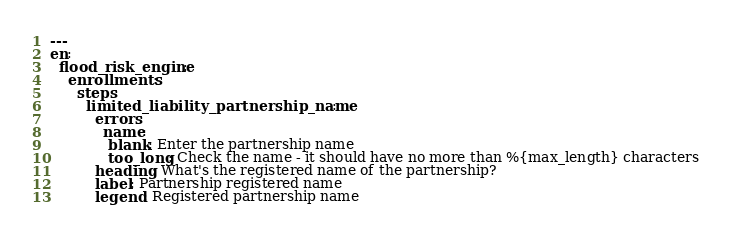Convert code to text. <code><loc_0><loc_0><loc_500><loc_500><_YAML_>---
en:
  flood_risk_engine:
    enrollments:
      steps:
        limited_liability_partnership_name:
          errors:
            name:
             blank: Enter the partnership name
             too_long: Check the name - it should have no more than %{max_length} characters
          heading: What's the registered name of the partnership?
          label: Partnership registered name
          legend: Registered partnership name
</code> 